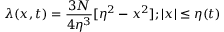Convert formula to latex. <formula><loc_0><loc_0><loc_500><loc_500>\lambda ( x , t ) = \frac { 3 N } { 4 \eta ^ { 3 } } [ \eta ^ { 2 } - x ^ { 2 } ] ; | x | \leq \eta ( t )</formula> 